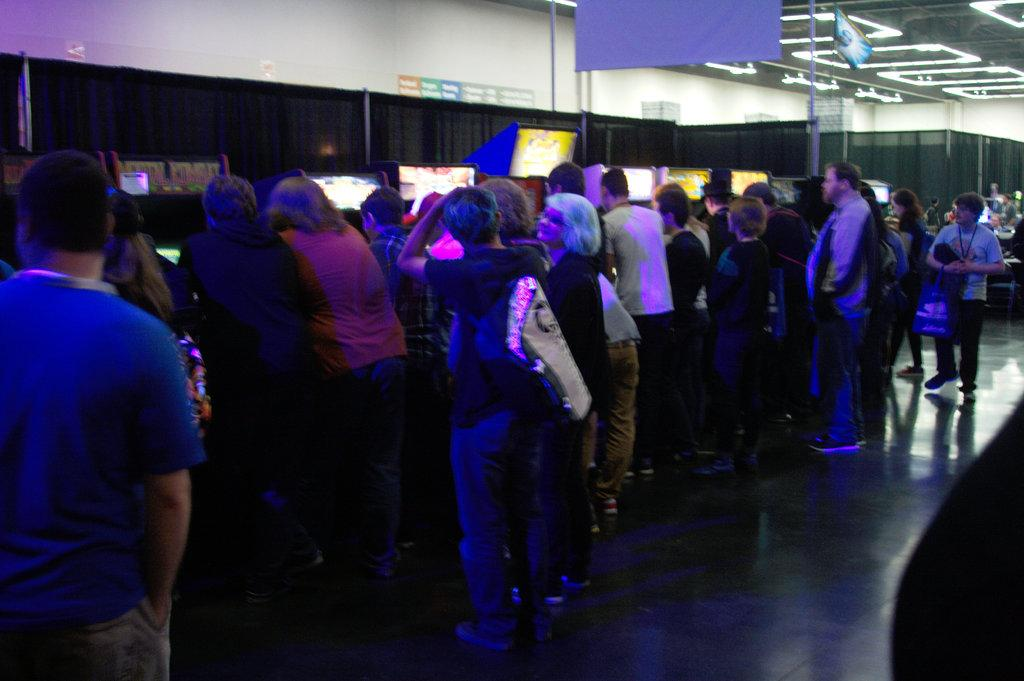What is the main subject of the image? The main subject of the image is a group of people. What can be seen on the wall in the image? There are display screens on the wall in the image. What type of lighting is present in the image? There are lights attached to the ceiling in the image. What type of tools does the carpenter use in the image? There is no carpenter present in the image, so it is not possible to determine what tools they might use. 